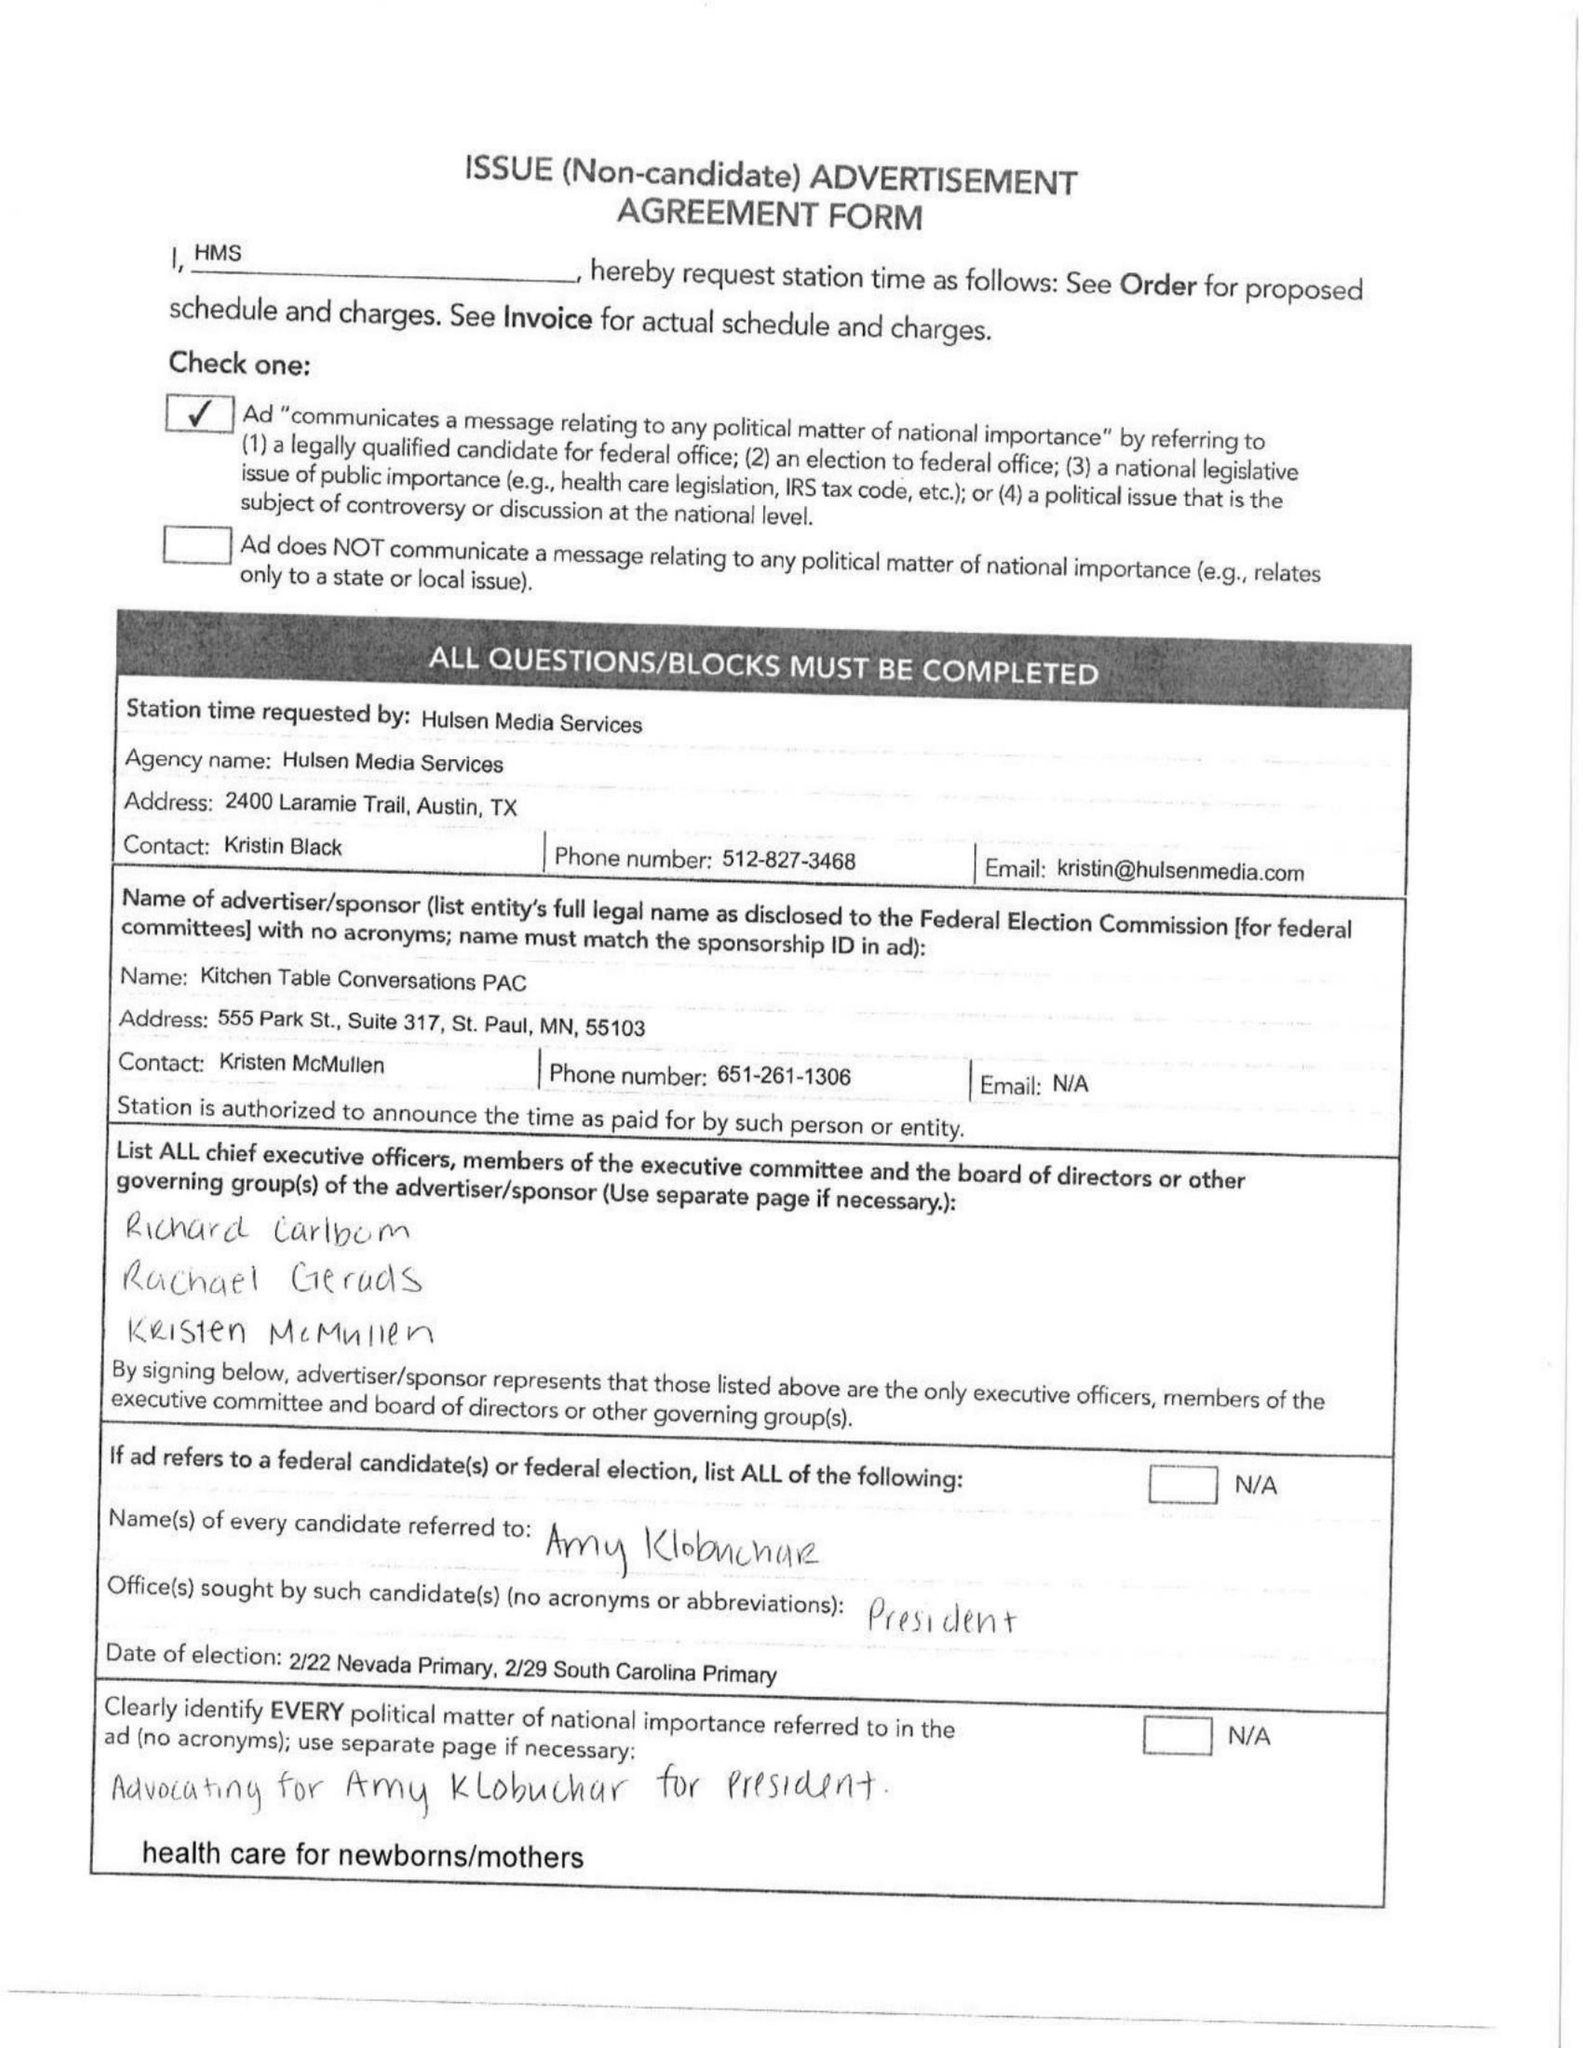What is the value for the flight_to?
Answer the question using a single word or phrase. 02/23/20 